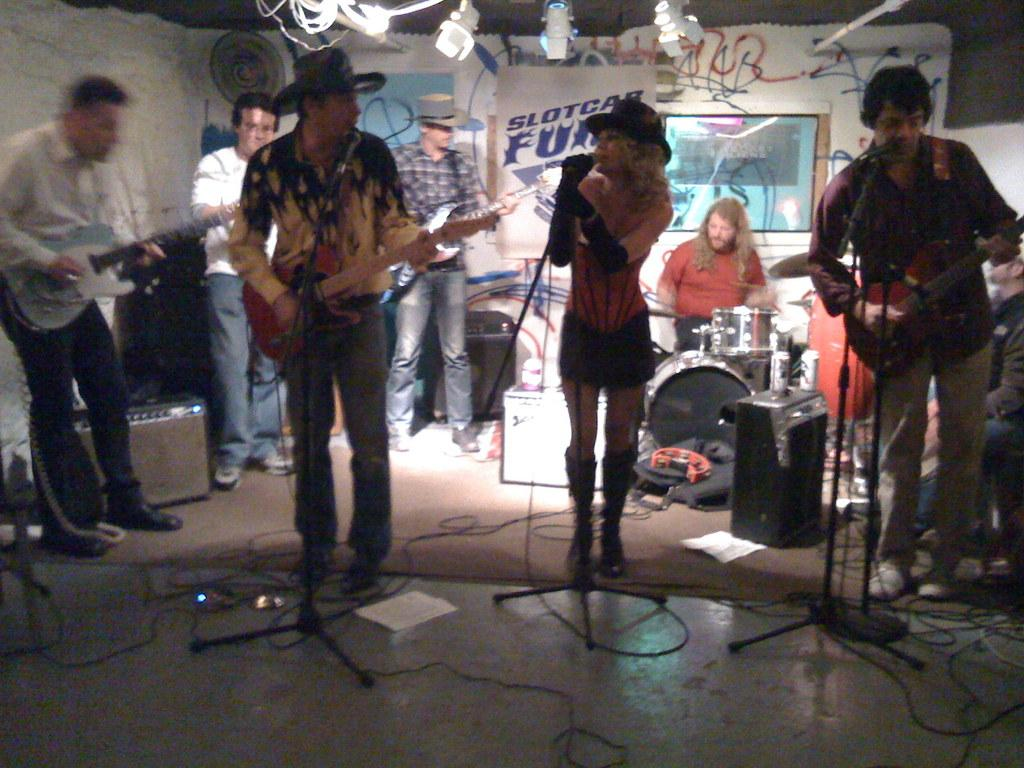What is the main activity happening in the image? The main activity in the image is a group of people playing music, with a central person singing and others playing guitar and drums. Can you describe the instruments being played in the image? Yes, there are guitars and drums being played in the image. What is written on the banner above the people? The banner above the people has the text "slot car" on it. What type of ghost can be seen in the image? There are no ghosts present in the image; it features a group of people playing music. How does the frame of the image affect the reaction of the viewers? The image does not have a frame, and therefore it cannot affect the reaction of the viewers. 